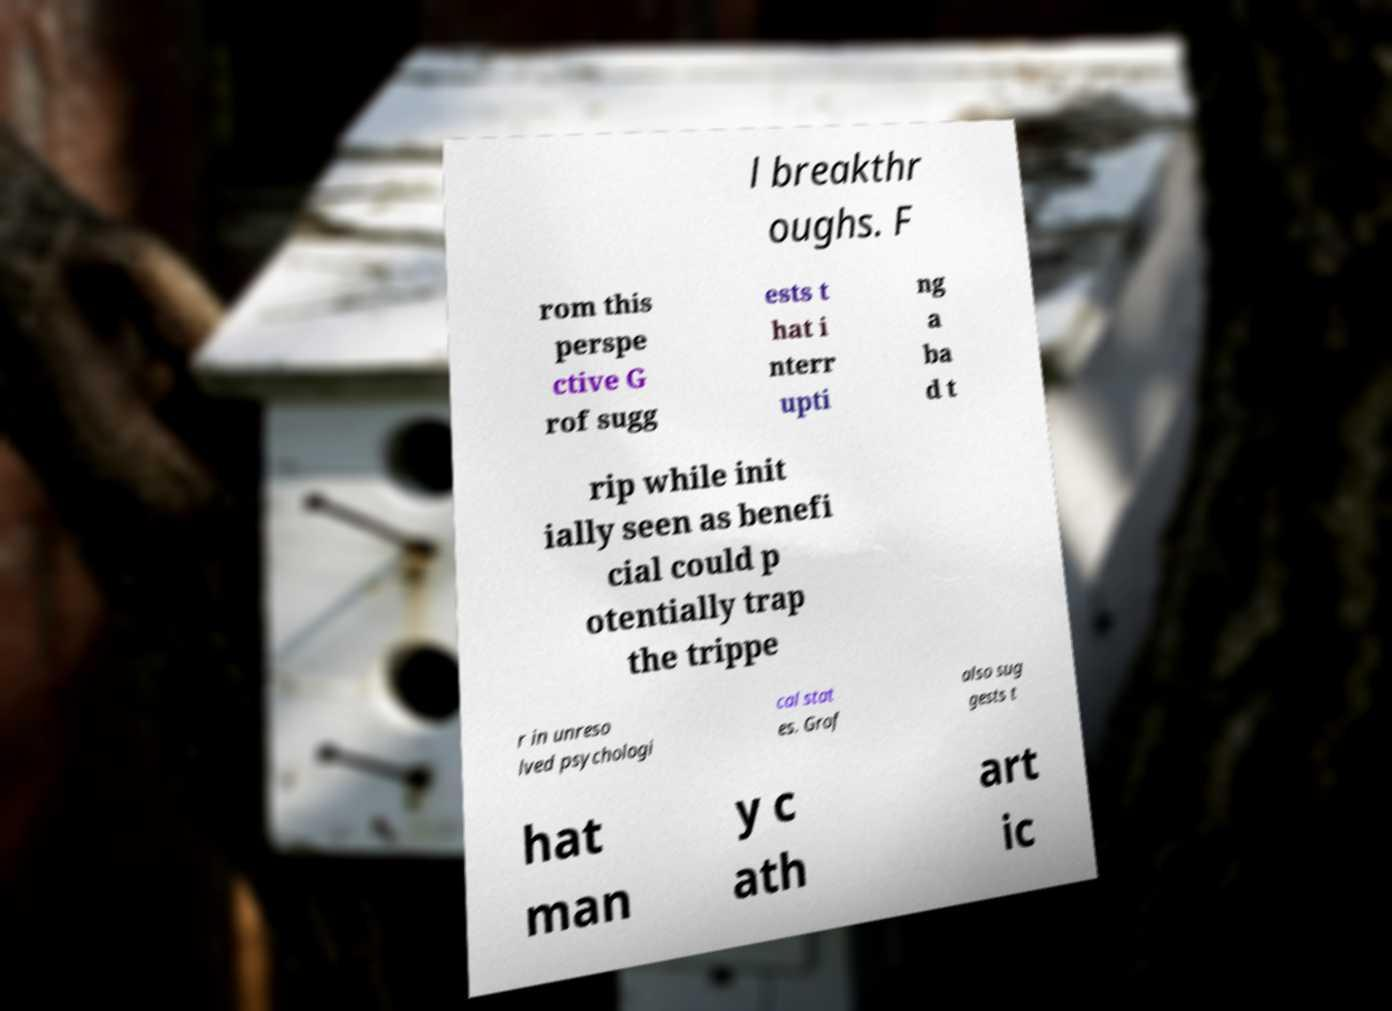What messages or text are displayed in this image? I need them in a readable, typed format. l breakthr oughs. F rom this perspe ctive G rof sugg ests t hat i nterr upti ng a ba d t rip while init ially seen as benefi cial could p otentially trap the trippe r in unreso lved psychologi cal stat es. Grof also sug gests t hat man y c ath art ic 